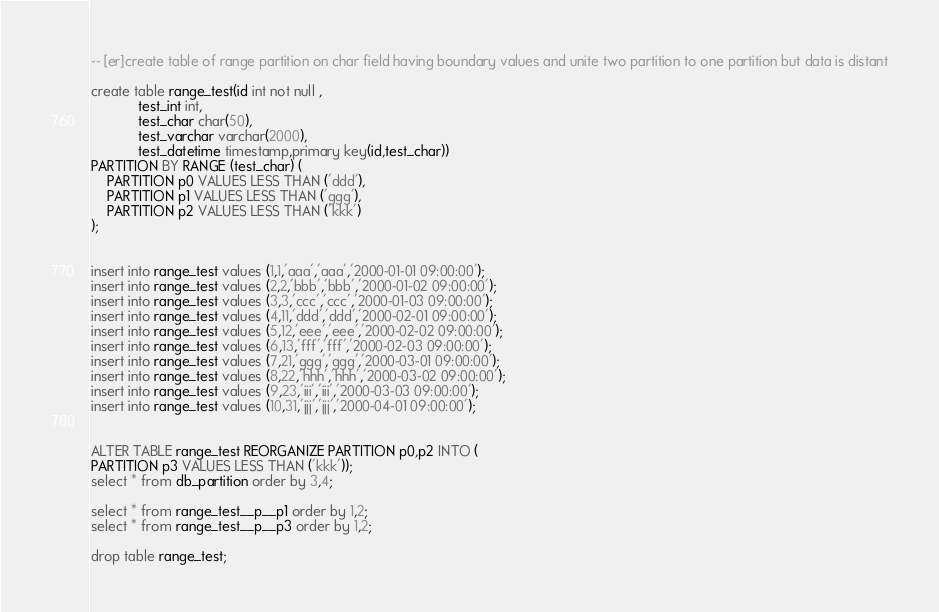Convert code to text. <code><loc_0><loc_0><loc_500><loc_500><_SQL_>-- [er]create table of range partition on char field having boundary values and unite two partition to one partition but data is distant

create table range_test(id int not null ,
			test_int int,
			test_char char(50),
			test_varchar varchar(2000),
			test_datetime timestamp,primary key(id,test_char))
PARTITION BY RANGE (test_char) (
    PARTITION p0 VALUES LESS THAN ('ddd'),
    PARTITION p1 VALUES LESS THAN ('ggg'),
    PARTITION p2 VALUES LESS THAN ('kkk')
);


insert into range_test values (1,1,'aaa','aaa','2000-01-01 09:00:00');
insert into range_test values (2,2,'bbb','bbb','2000-01-02 09:00:00');
insert into range_test values (3,3,'ccc','ccc','2000-01-03 09:00:00');
insert into range_test values (4,11,'ddd','ddd','2000-02-01 09:00:00');
insert into range_test values (5,12,'eee','eee','2000-02-02 09:00:00');
insert into range_test values (6,13,'fff','fff','2000-02-03 09:00:00');
insert into range_test values (7,21,'ggg','ggg','2000-03-01 09:00:00');
insert into range_test values (8,22,'hhh','hhh','2000-03-02 09:00:00');
insert into range_test values (9,23,'iii','iii','2000-03-03 09:00:00');
insert into range_test values (10,31,'jjj','jjj','2000-04-01 09:00:00');


ALTER TABLE range_test REORGANIZE PARTITION p0,p2 INTO ( 
PARTITION p3 VALUES LESS THAN ('kkk'));
select * from db_partition order by 3,4;

select * from range_test__p__p1 order by 1,2;
select * from range_test__p__p3 order by 1,2;

drop table range_test;
</code> 